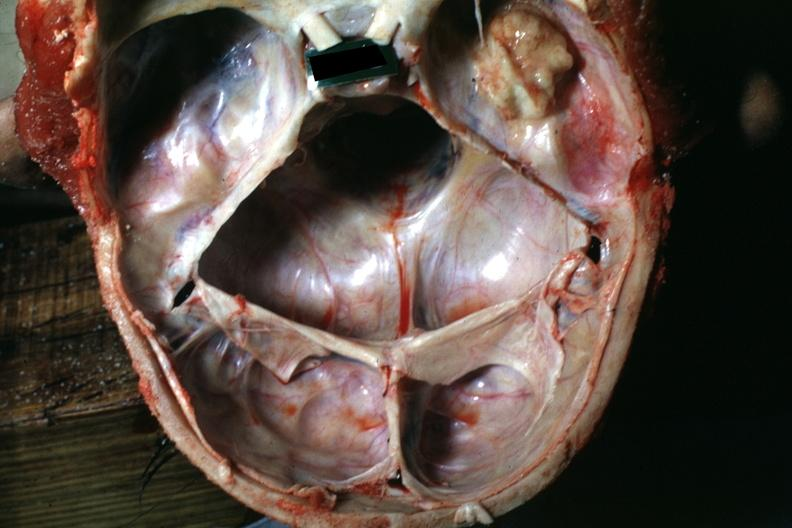s bone, calvarium present?
Answer the question using a single word or phrase. Yes 